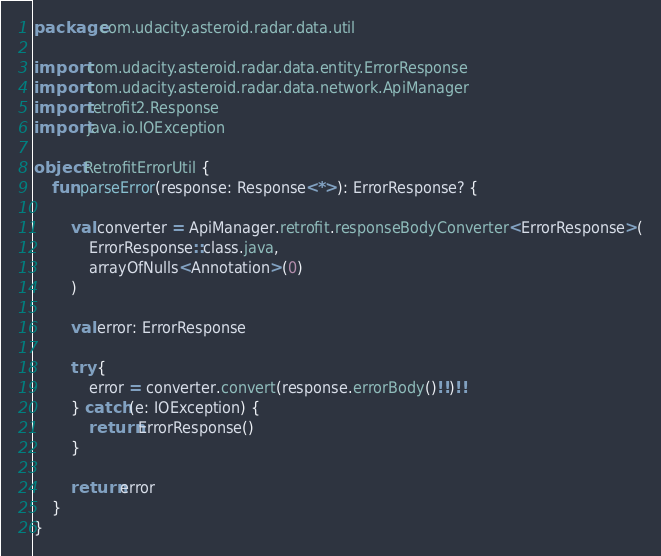Convert code to text. <code><loc_0><loc_0><loc_500><loc_500><_Kotlin_>package com.udacity.asteroid.radar.data.util

import com.udacity.asteroid.radar.data.entity.ErrorResponse
import com.udacity.asteroid.radar.data.network.ApiManager
import retrofit2.Response
import java.io.IOException

object RetrofitErrorUtil {
    fun parseError(response: Response<*>): ErrorResponse? {

        val converter = ApiManager.retrofit.responseBodyConverter<ErrorResponse>(
            ErrorResponse::class.java,
            arrayOfNulls<Annotation>(0)
        )

        val error: ErrorResponse

        try {
            error = converter.convert(response.errorBody()!!)!!
        } catch (e: IOException) {
            return ErrorResponse()
        }

        return error
    }
}</code> 